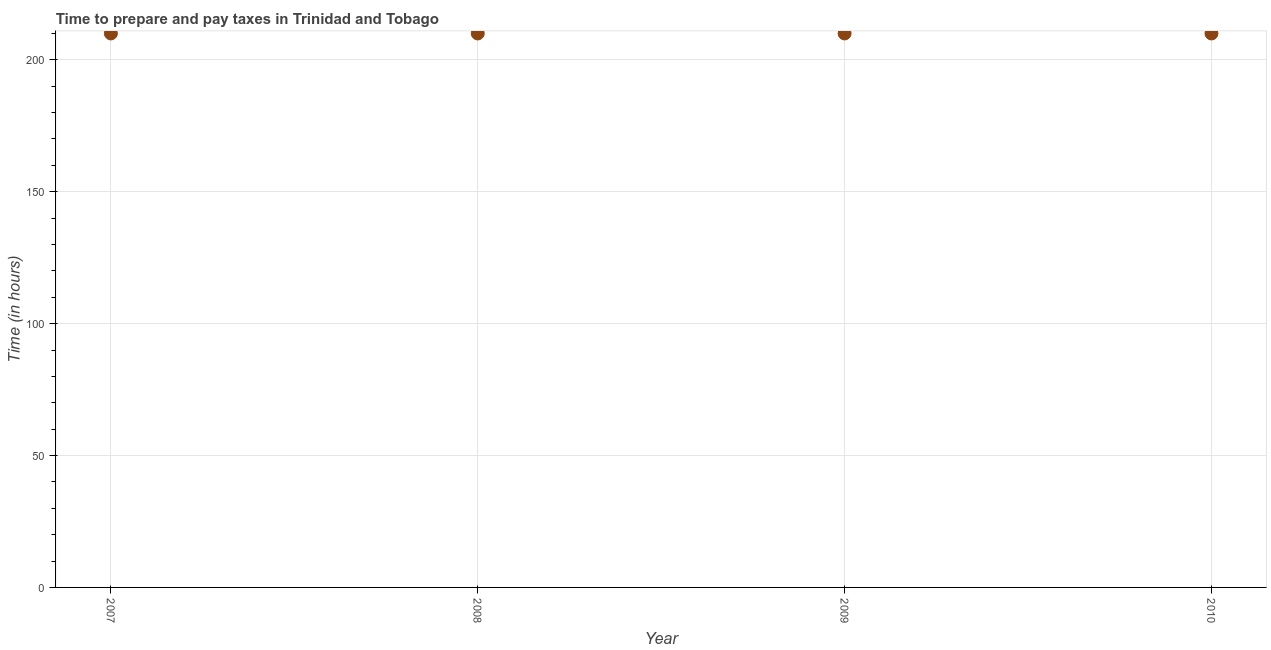What is the time to prepare and pay taxes in 2007?
Give a very brief answer. 210. Across all years, what is the maximum time to prepare and pay taxes?
Ensure brevity in your answer.  210. Across all years, what is the minimum time to prepare and pay taxes?
Offer a terse response. 210. In which year was the time to prepare and pay taxes maximum?
Offer a terse response. 2007. In which year was the time to prepare and pay taxes minimum?
Provide a succinct answer. 2007. What is the sum of the time to prepare and pay taxes?
Offer a terse response. 840. What is the average time to prepare and pay taxes per year?
Ensure brevity in your answer.  210. What is the median time to prepare and pay taxes?
Provide a short and direct response. 210. In how many years, is the time to prepare and pay taxes greater than 100 hours?
Your answer should be compact. 4. Do a majority of the years between 2007 and 2008 (inclusive) have time to prepare and pay taxes greater than 130 hours?
Ensure brevity in your answer.  Yes. Is the time to prepare and pay taxes in 2007 less than that in 2008?
Offer a very short reply. No. What is the difference between the highest and the second highest time to prepare and pay taxes?
Your answer should be compact. 0. Is the sum of the time to prepare and pay taxes in 2009 and 2010 greater than the maximum time to prepare and pay taxes across all years?
Provide a succinct answer. Yes. In how many years, is the time to prepare and pay taxes greater than the average time to prepare and pay taxes taken over all years?
Your answer should be compact. 0. How many dotlines are there?
Offer a very short reply. 1. How many years are there in the graph?
Ensure brevity in your answer.  4. What is the title of the graph?
Offer a very short reply. Time to prepare and pay taxes in Trinidad and Tobago. What is the label or title of the X-axis?
Provide a succinct answer. Year. What is the label or title of the Y-axis?
Provide a short and direct response. Time (in hours). What is the Time (in hours) in 2007?
Your response must be concise. 210. What is the Time (in hours) in 2008?
Your answer should be very brief. 210. What is the Time (in hours) in 2009?
Your answer should be very brief. 210. What is the Time (in hours) in 2010?
Your answer should be very brief. 210. What is the difference between the Time (in hours) in 2007 and 2009?
Ensure brevity in your answer.  0. What is the ratio of the Time (in hours) in 2007 to that in 2008?
Give a very brief answer. 1. What is the ratio of the Time (in hours) in 2007 to that in 2009?
Make the answer very short. 1. What is the ratio of the Time (in hours) in 2008 to that in 2010?
Keep it short and to the point. 1. 